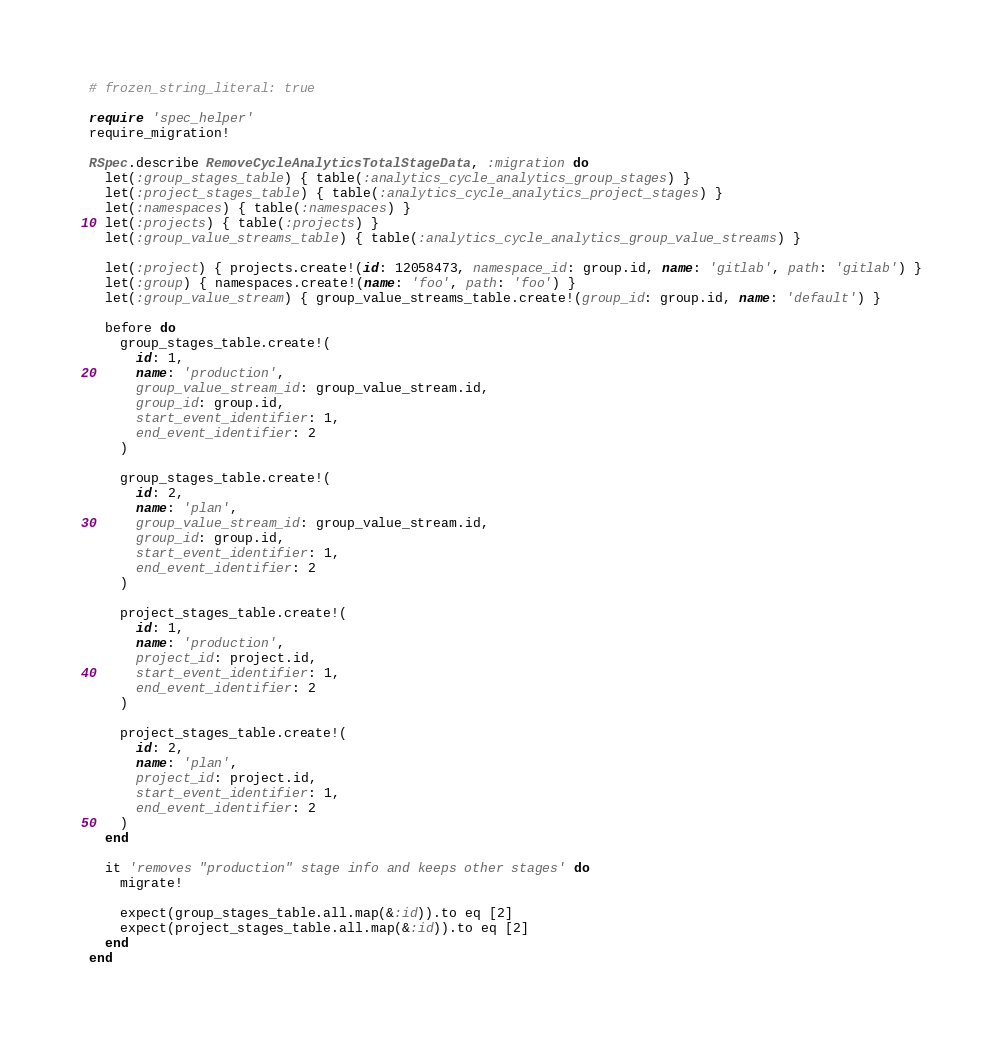<code> <loc_0><loc_0><loc_500><loc_500><_Ruby_># frozen_string_literal: true

require 'spec_helper'
require_migration!

RSpec.describe RemoveCycleAnalyticsTotalStageData, :migration do
  let(:group_stages_table) { table(:analytics_cycle_analytics_group_stages) }
  let(:project_stages_table) { table(:analytics_cycle_analytics_project_stages) }
  let(:namespaces) { table(:namespaces) }
  let(:projects) { table(:projects) }
  let(:group_value_streams_table) { table(:analytics_cycle_analytics_group_value_streams) }

  let(:project) { projects.create!(id: 12058473, namespace_id: group.id, name: 'gitlab', path: 'gitlab') }
  let(:group) { namespaces.create!(name: 'foo', path: 'foo') }
  let(:group_value_stream) { group_value_streams_table.create!(group_id: group.id, name: 'default') }

  before do
    group_stages_table.create!(
      id: 1,
      name: 'production',
      group_value_stream_id: group_value_stream.id,
      group_id: group.id,
      start_event_identifier: 1,
      end_event_identifier: 2
    )

    group_stages_table.create!(
      id: 2,
      name: 'plan',
      group_value_stream_id: group_value_stream.id,
      group_id: group.id,
      start_event_identifier: 1,
      end_event_identifier: 2
    )

    project_stages_table.create!(
      id: 1,
      name: 'production',
      project_id: project.id,
      start_event_identifier: 1,
      end_event_identifier: 2
    )

    project_stages_table.create!(
      id: 2,
      name: 'plan',
      project_id: project.id,
      start_event_identifier: 1,
      end_event_identifier: 2
    )
  end

  it 'removes "production" stage info and keeps other stages' do
    migrate!

    expect(group_stages_table.all.map(&:id)).to eq [2]
    expect(project_stages_table.all.map(&:id)).to eq [2]
  end
end
</code> 